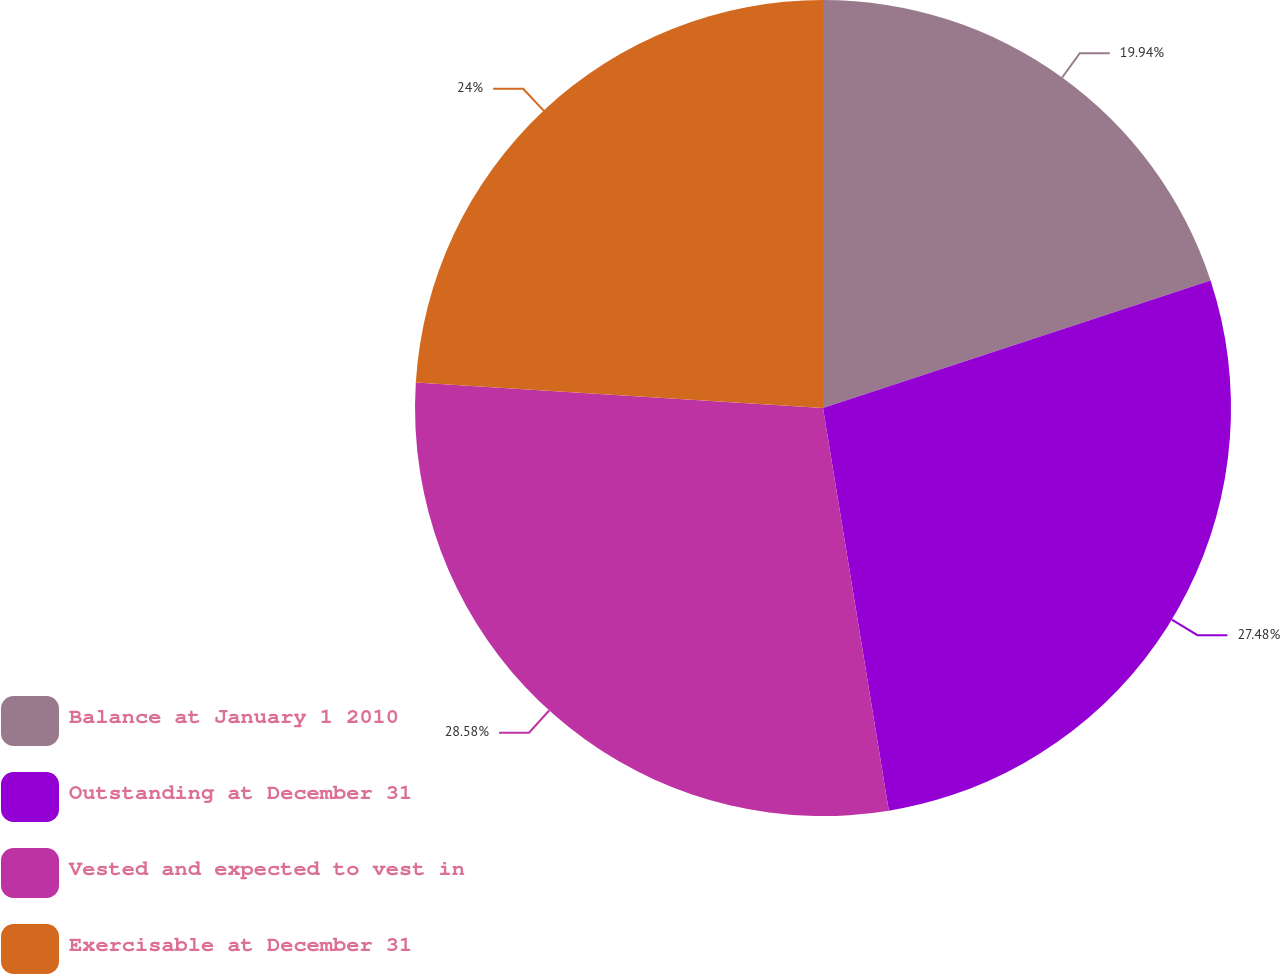Convert chart to OTSL. <chart><loc_0><loc_0><loc_500><loc_500><pie_chart><fcel>Balance at January 1 2010<fcel>Outstanding at December 31<fcel>Vested and expected to vest in<fcel>Exercisable at December 31<nl><fcel>19.94%<fcel>27.48%<fcel>28.58%<fcel>24.0%<nl></chart> 